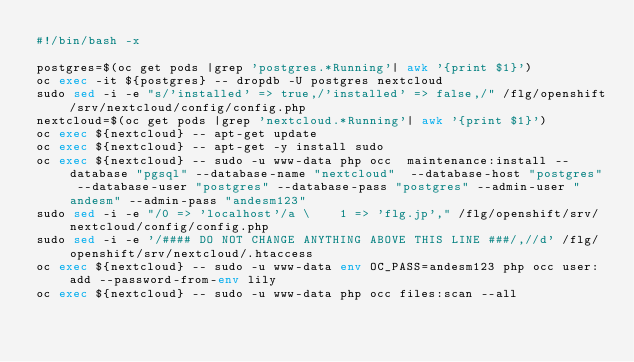<code> <loc_0><loc_0><loc_500><loc_500><_Bash_>#!/bin/bash -x

postgres=$(oc get pods |grep 'postgres.*Running'| awk '{print $1}')
oc exec -it ${postgres} -- dropdb -U postgres nextcloud
sudo sed -i -e "s/'installed' => true,/'installed' => false,/" /flg/openshift/srv/nextcloud/config/config.php
nextcloud=$(oc get pods |grep 'nextcloud.*Running'| awk '{print $1}')
oc exec ${nextcloud} -- apt-get update
oc exec ${nextcloud} -- apt-get -y install sudo 
oc exec ${nextcloud} -- sudo -u www-data php occ  maintenance:install --database "pgsql" --database-name "nextcloud"  --database-host "postgres" --database-user "postgres" --database-pass "postgres" --admin-user "andesm" --admin-pass "andesm123"
sudo sed -i -e "/0 => 'localhost'/a \    1 => 'flg.jp'," /flg/openshift/srv/nextcloud/config/config.php
sudo sed -i -e '/#### DO NOT CHANGE ANYTHING ABOVE THIS LINE ###/,//d' /flg/openshift/srv/nextcloud/.htaccess
oc exec ${nextcloud} -- sudo -u www-data env OC_PASS=andesm123 php occ user:add --password-from-env lily
oc exec ${nextcloud} -- sudo -u www-data php occ files:scan --all

</code> 